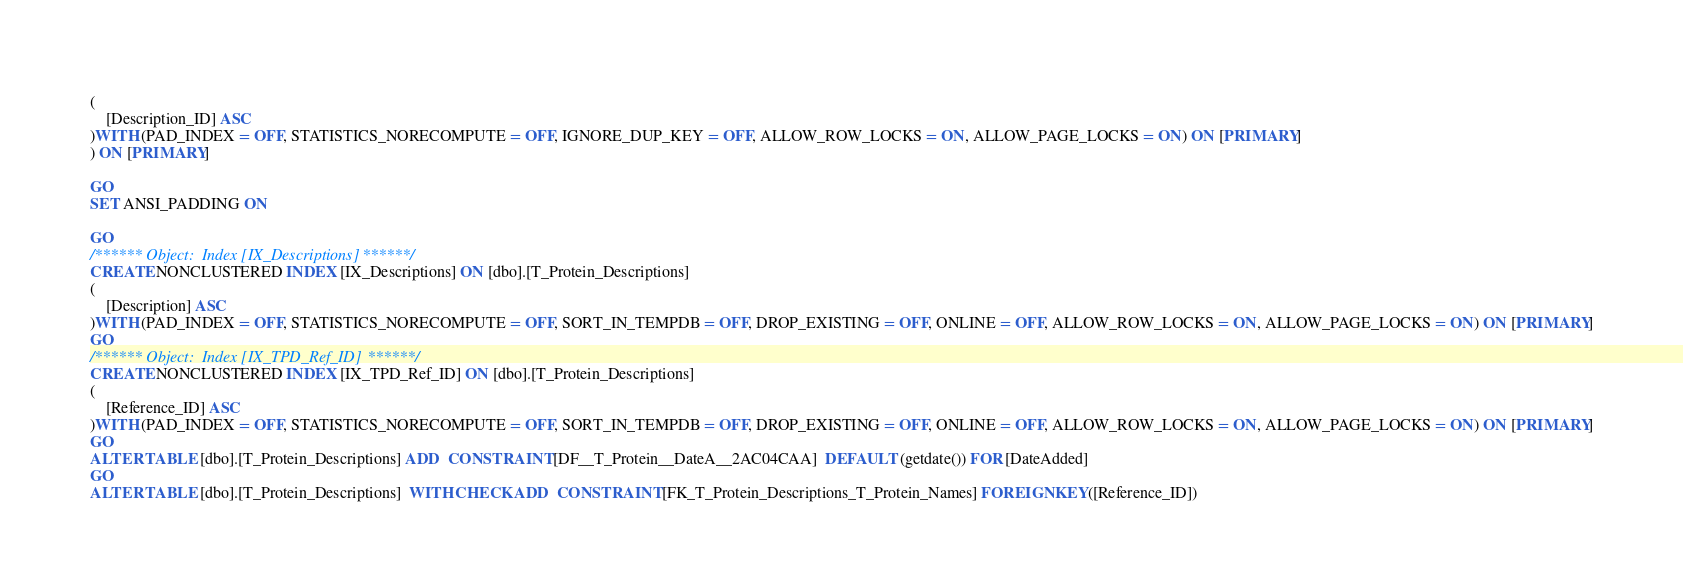Convert code to text. <code><loc_0><loc_0><loc_500><loc_500><_SQL_>(
	[Description_ID] ASC
)WITH (PAD_INDEX = OFF, STATISTICS_NORECOMPUTE = OFF, IGNORE_DUP_KEY = OFF, ALLOW_ROW_LOCKS = ON, ALLOW_PAGE_LOCKS = ON) ON [PRIMARY]
) ON [PRIMARY]

GO
SET ANSI_PADDING ON

GO
/****** Object:  Index [IX_Descriptions] ******/
CREATE NONCLUSTERED INDEX [IX_Descriptions] ON [dbo].[T_Protein_Descriptions]
(
	[Description] ASC
)WITH (PAD_INDEX = OFF, STATISTICS_NORECOMPUTE = OFF, SORT_IN_TEMPDB = OFF, DROP_EXISTING = OFF, ONLINE = OFF, ALLOW_ROW_LOCKS = ON, ALLOW_PAGE_LOCKS = ON) ON [PRIMARY]
GO
/****** Object:  Index [IX_TPD_Ref_ID] ******/
CREATE NONCLUSTERED INDEX [IX_TPD_Ref_ID] ON [dbo].[T_Protein_Descriptions]
(
	[Reference_ID] ASC
)WITH (PAD_INDEX = OFF, STATISTICS_NORECOMPUTE = OFF, SORT_IN_TEMPDB = OFF, DROP_EXISTING = OFF, ONLINE = OFF, ALLOW_ROW_LOCKS = ON, ALLOW_PAGE_LOCKS = ON) ON [PRIMARY]
GO
ALTER TABLE [dbo].[T_Protein_Descriptions] ADD  CONSTRAINT [DF__T_Protein__DateA__2AC04CAA]  DEFAULT (getdate()) FOR [DateAdded]
GO
ALTER TABLE [dbo].[T_Protein_Descriptions]  WITH CHECK ADD  CONSTRAINT [FK_T_Protein_Descriptions_T_Protein_Names] FOREIGN KEY([Reference_ID])</code> 